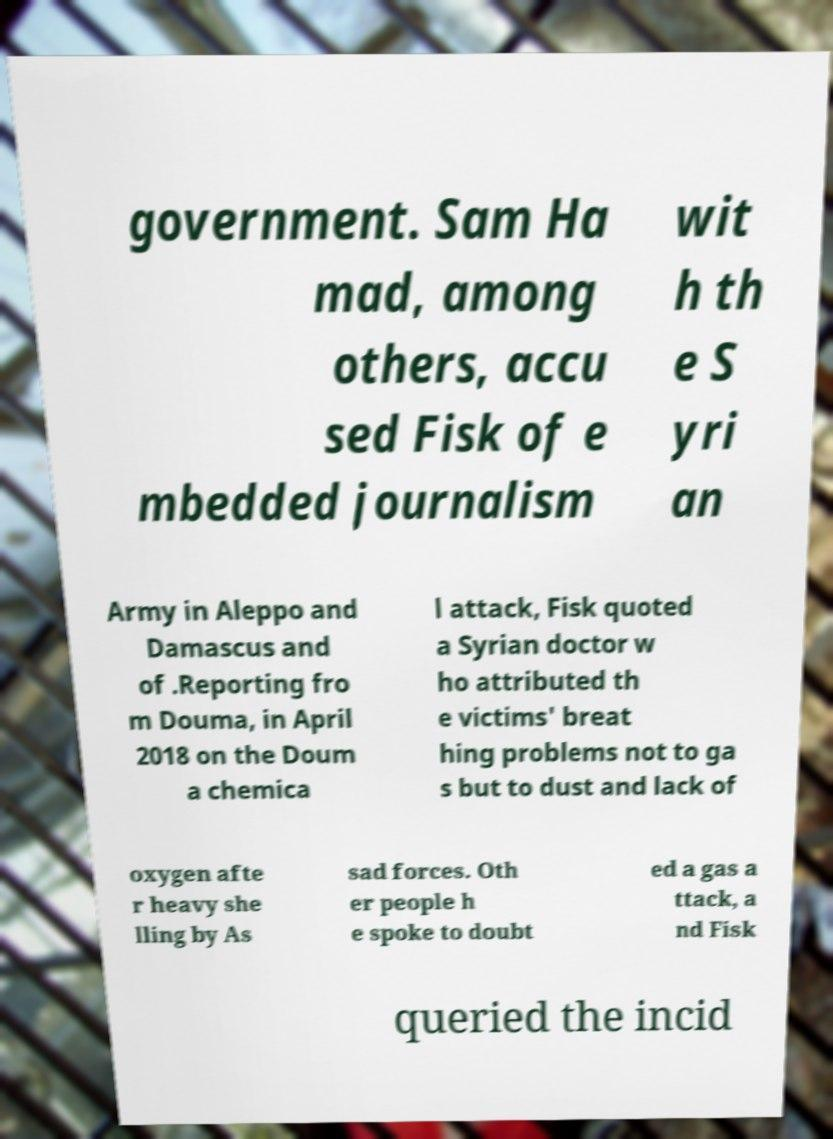Can you read and provide the text displayed in the image?This photo seems to have some interesting text. Can you extract and type it out for me? government. Sam Ha mad, among others, accu sed Fisk of e mbedded journalism wit h th e S yri an Army in Aleppo and Damascus and of .Reporting fro m Douma, in April 2018 on the Doum a chemica l attack, Fisk quoted a Syrian doctor w ho attributed th e victims' breat hing problems not to ga s but to dust and lack of oxygen afte r heavy she lling by As sad forces. Oth er people h e spoke to doubt ed a gas a ttack, a nd Fisk queried the incid 